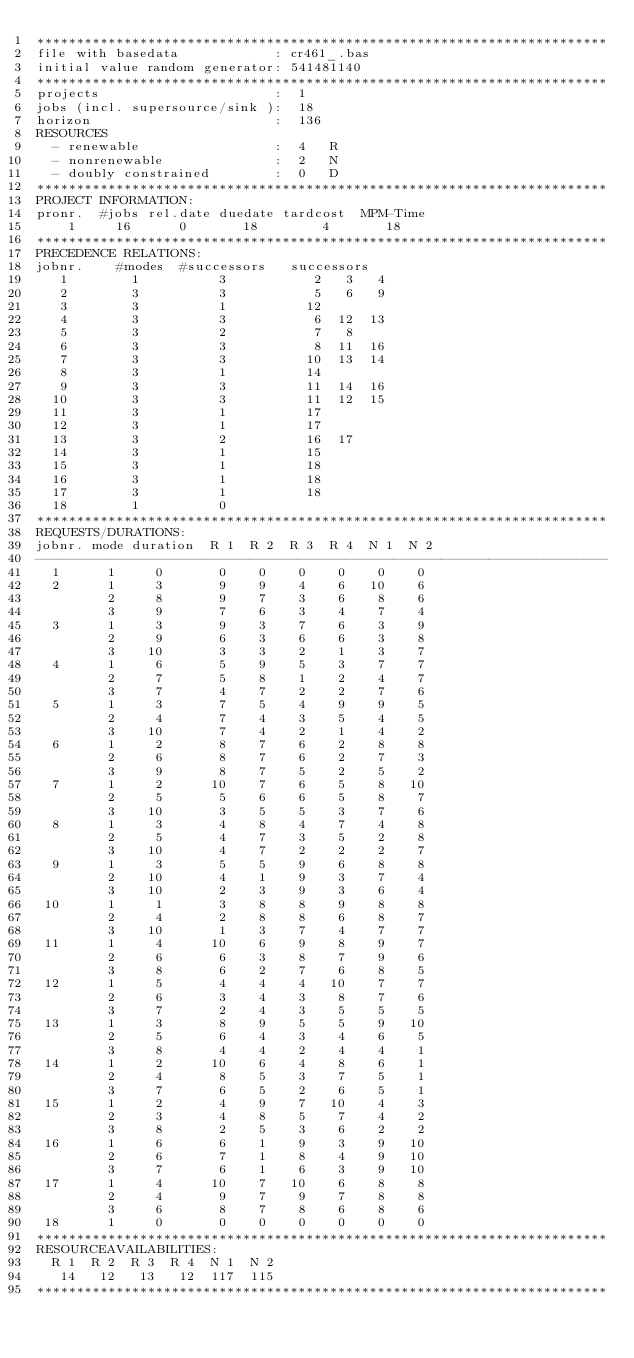<code> <loc_0><loc_0><loc_500><loc_500><_ObjectiveC_>************************************************************************
file with basedata            : cr461_.bas
initial value random generator: 541481140
************************************************************************
projects                      :  1
jobs (incl. supersource/sink ):  18
horizon                       :  136
RESOURCES
  - renewable                 :  4   R
  - nonrenewable              :  2   N
  - doubly constrained        :  0   D
************************************************************************
PROJECT INFORMATION:
pronr.  #jobs rel.date duedate tardcost  MPM-Time
    1     16      0       18        4       18
************************************************************************
PRECEDENCE RELATIONS:
jobnr.    #modes  #successors   successors
   1        1          3           2   3   4
   2        3          3           5   6   9
   3        3          1          12
   4        3          3           6  12  13
   5        3          2           7   8
   6        3          3           8  11  16
   7        3          3          10  13  14
   8        3          1          14
   9        3          3          11  14  16
  10        3          3          11  12  15
  11        3          1          17
  12        3          1          17
  13        3          2          16  17
  14        3          1          15
  15        3          1          18
  16        3          1          18
  17        3          1          18
  18        1          0        
************************************************************************
REQUESTS/DURATIONS:
jobnr. mode duration  R 1  R 2  R 3  R 4  N 1  N 2
------------------------------------------------------------------------
  1      1     0       0    0    0    0    0    0
  2      1     3       9    9    4    6   10    6
         2     8       9    7    3    6    8    6
         3     9       7    6    3    4    7    4
  3      1     3       9    3    7    6    3    9
         2     9       6    3    6    6    3    8
         3    10       3    3    2    1    3    7
  4      1     6       5    9    5    3    7    7
         2     7       5    8    1    2    4    7
         3     7       4    7    2    2    7    6
  5      1     3       7    5    4    9    9    5
         2     4       7    4    3    5    4    5
         3    10       7    4    2    1    4    2
  6      1     2       8    7    6    2    8    8
         2     6       8    7    6    2    7    3
         3     9       8    7    5    2    5    2
  7      1     2      10    7    6    5    8   10
         2     5       5    6    6    5    8    7
         3    10       3    5    5    3    7    6
  8      1     3       4    8    4    7    4    8
         2     5       4    7    3    5    2    8
         3    10       4    7    2    2    2    7
  9      1     3       5    5    9    6    8    8
         2    10       4    1    9    3    7    4
         3    10       2    3    9    3    6    4
 10      1     1       3    8    8    9    8    8
         2     4       2    8    8    6    8    7
         3    10       1    3    7    4    7    7
 11      1     4      10    6    9    8    9    7
         2     6       6    3    8    7    9    6
         3     8       6    2    7    6    8    5
 12      1     5       4    4    4   10    7    7
         2     6       3    4    3    8    7    6
         3     7       2    4    3    5    5    5
 13      1     3       8    9    5    5    9   10
         2     5       6    4    3    4    6    5
         3     8       4    4    2    4    4    1
 14      1     2      10    6    4    8    6    1
         2     4       8    5    3    7    5    1
         3     7       6    5    2    6    5    1
 15      1     2       4    9    7   10    4    3
         2     3       4    8    5    7    4    2
         3     8       2    5    3    6    2    2
 16      1     6       6    1    9    3    9   10
         2     6       7    1    8    4    9   10
         3     7       6    1    6    3    9   10
 17      1     4      10    7   10    6    8    8
         2     4       9    7    9    7    8    8
         3     6       8    7    8    6    8    6
 18      1     0       0    0    0    0    0    0
************************************************************************
RESOURCEAVAILABILITIES:
  R 1  R 2  R 3  R 4  N 1  N 2
   14   12   13   12  117  115
************************************************************************
</code> 